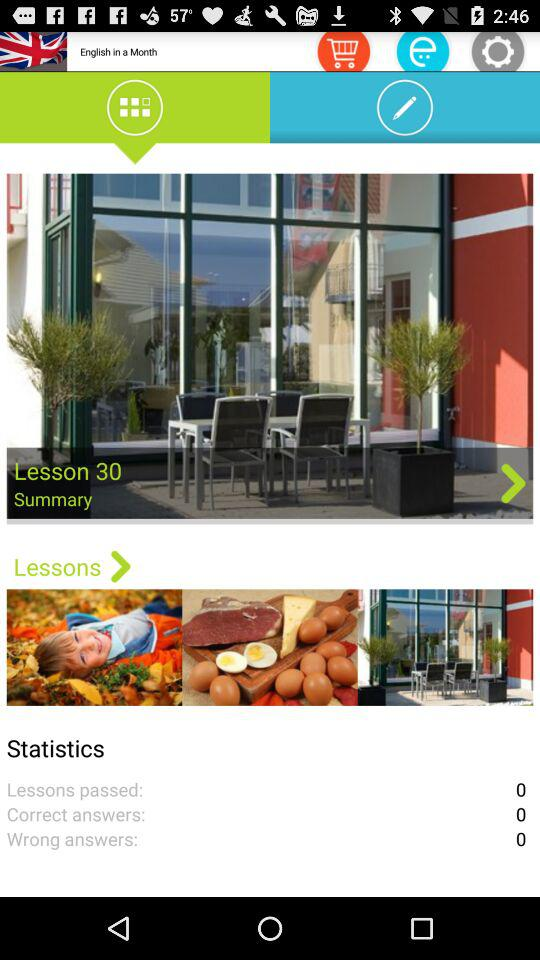How many wrong answers are there? There are 0 wrong answers. 